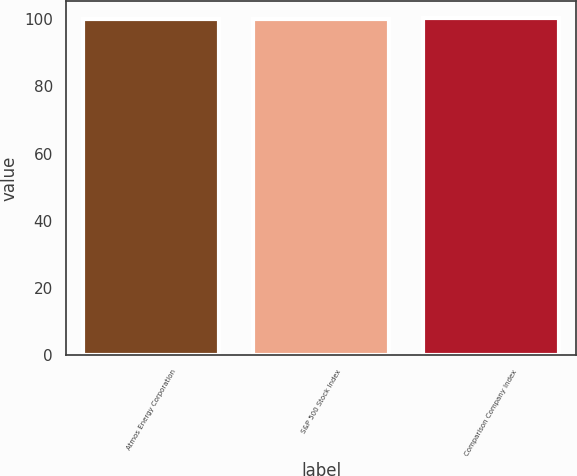Convert chart to OTSL. <chart><loc_0><loc_0><loc_500><loc_500><bar_chart><fcel>Atmos Energy Corporation<fcel>S&P 500 Stock Index<fcel>Comparison Company Index<nl><fcel>100<fcel>100.1<fcel>100.2<nl></chart> 